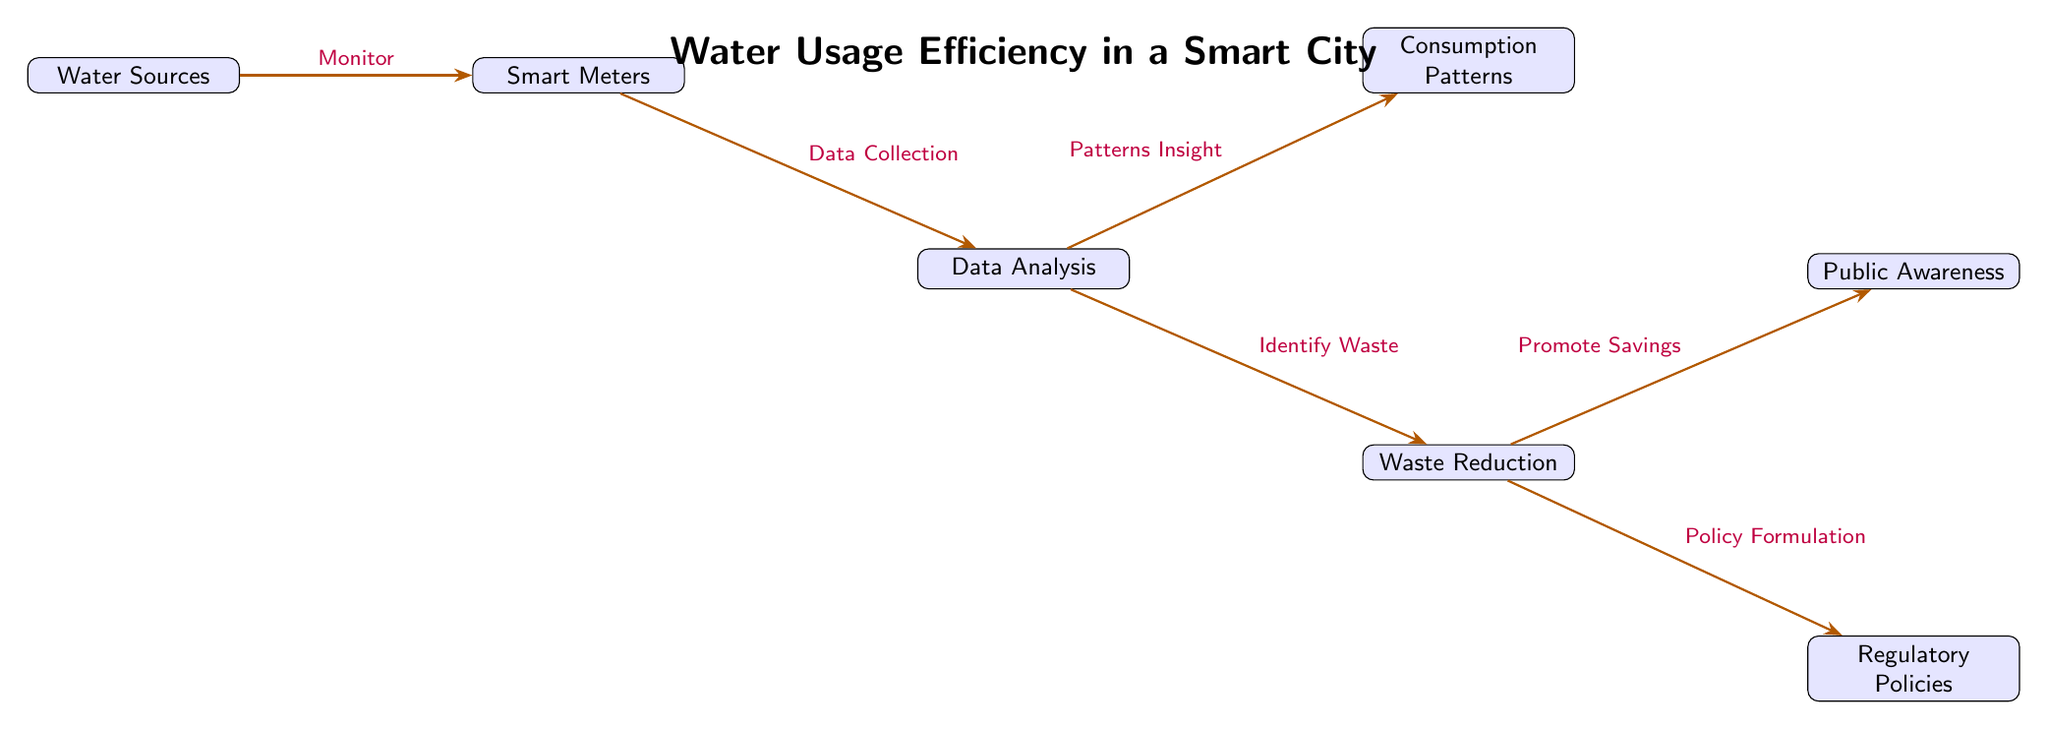What are the main components in the diagram? The diagram depicts several main components including Water Sources, Smart Meters, Data Analysis, Consumption Patterns, Waste Reduction, Public Awareness, and Regulatory Policies.
Answer: Water Sources, Smart Meters, Data Analysis, Consumption Patterns, Waste Reduction, Public Awareness, Regulatory Policies How many nodes are present in the diagram? By counting all the boxes (nodes) in the diagram, we find a total of seven nodes.
Answer: 7 What is the function of Smart Meters in this diagram? Smart Meters are connected to Water Sources for monitoring purposes, indicating they play a role in observing water usage.
Answer: Monitor Which component follows Data Analysis in the flow of the diagram? After Data Analysis, the two components that follow are Consumption Patterns and Waste Reduction, but Consumption Patterns is positioned above, making it the first in the lower level of the flow.
Answer: Consumption Patterns How does Waste Reduction connect to Public Awareness? Waste Reduction promotes savings, which directly connects to Public Awareness, indicating a relationship focused on raising awareness about savings achieved.
Answer: Promote Savings Which node is responsible for identifying waste? Waste Reduction is the node specifically mentioned for identifying waste in the consumption process.
Answer: Identify Waste Can you identify the number of edges originating from Data Analysis? Data Analysis has two edges stemming from it, leading to Consumption Patterns and Waste Reduction, showcasing its role in steering these areas.
Answer: 2 What is indicated as the last node in the diagram? The last node in the flow sequence is Regulatory Policies, which is positioned further along at the bottom level of the diagram.
Answer: Regulatory Policies Which component contributes to both Public Awareness and Regulatory Policies? Waste Reduction is the common node that contributes to both Public Awareness (through promoting savings) and Regulatory Policies (through policy formulation).
Answer: Waste Reduction 